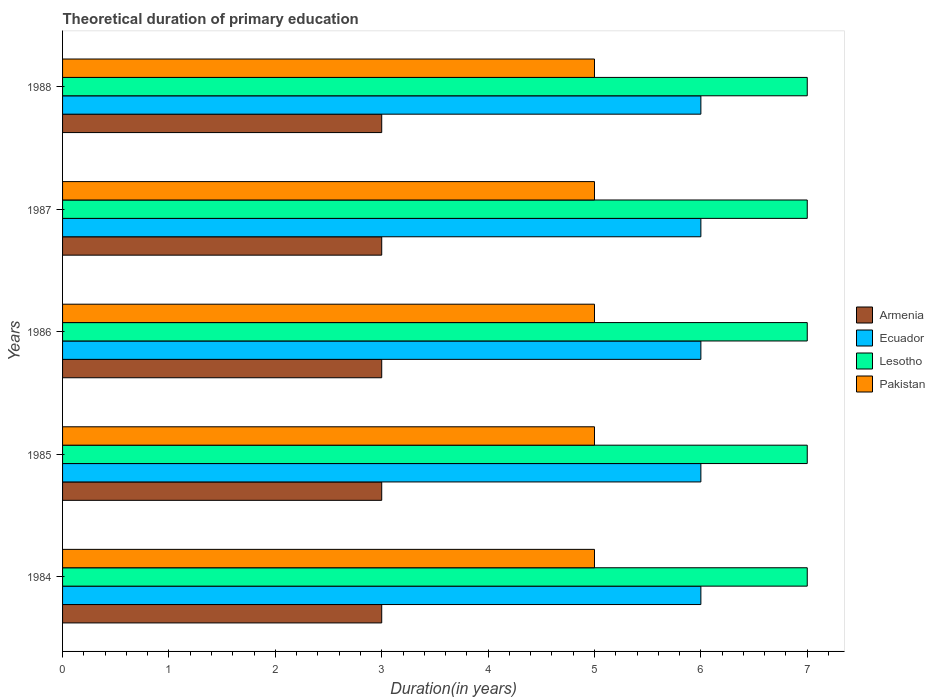How many different coloured bars are there?
Offer a very short reply. 4. How many groups of bars are there?
Give a very brief answer. 5. Are the number of bars on each tick of the Y-axis equal?
Provide a short and direct response. Yes. How many bars are there on the 5th tick from the top?
Your response must be concise. 4. What is the label of the 3rd group of bars from the top?
Provide a short and direct response. 1986. In how many cases, is the number of bars for a given year not equal to the number of legend labels?
Give a very brief answer. 0. Across all years, what is the maximum total theoretical duration of primary education in Pakistan?
Your answer should be compact. 5. Across all years, what is the minimum total theoretical duration of primary education in Armenia?
Give a very brief answer. 3. In which year was the total theoretical duration of primary education in Ecuador maximum?
Ensure brevity in your answer.  1984. In which year was the total theoretical duration of primary education in Armenia minimum?
Your answer should be compact. 1984. What is the total total theoretical duration of primary education in Lesotho in the graph?
Your answer should be compact. 35. What is the difference between the total theoretical duration of primary education in Ecuador in 1987 and the total theoretical duration of primary education in Pakistan in 1984?
Your answer should be compact. 1. In the year 1987, what is the difference between the total theoretical duration of primary education in Armenia and total theoretical duration of primary education in Ecuador?
Your answer should be very brief. -3. In how many years, is the total theoretical duration of primary education in Pakistan greater than 4.2 years?
Offer a terse response. 5. Is the difference between the total theoretical duration of primary education in Armenia in 1984 and 1986 greater than the difference between the total theoretical duration of primary education in Ecuador in 1984 and 1986?
Make the answer very short. No. Is it the case that in every year, the sum of the total theoretical duration of primary education in Ecuador and total theoretical duration of primary education in Armenia is greater than the sum of total theoretical duration of primary education in Lesotho and total theoretical duration of primary education in Pakistan?
Provide a short and direct response. No. What does the 1st bar from the top in 1985 represents?
Give a very brief answer. Pakistan. What does the 2nd bar from the bottom in 1986 represents?
Provide a succinct answer. Ecuador. Is it the case that in every year, the sum of the total theoretical duration of primary education in Pakistan and total theoretical duration of primary education in Armenia is greater than the total theoretical duration of primary education in Ecuador?
Your response must be concise. Yes. How many years are there in the graph?
Your response must be concise. 5. What is the difference between two consecutive major ticks on the X-axis?
Keep it short and to the point. 1. Does the graph contain any zero values?
Provide a short and direct response. No. Does the graph contain grids?
Keep it short and to the point. No. How are the legend labels stacked?
Make the answer very short. Vertical. What is the title of the graph?
Your answer should be compact. Theoretical duration of primary education. What is the label or title of the X-axis?
Keep it short and to the point. Duration(in years). What is the label or title of the Y-axis?
Provide a succinct answer. Years. What is the Duration(in years) in Armenia in 1984?
Make the answer very short. 3. What is the Duration(in years) of Pakistan in 1984?
Offer a very short reply. 5. What is the Duration(in years) of Armenia in 1985?
Your answer should be very brief. 3. What is the Duration(in years) in Ecuador in 1985?
Give a very brief answer. 6. What is the Duration(in years) of Lesotho in 1985?
Offer a terse response. 7. What is the Duration(in years) in Armenia in 1986?
Ensure brevity in your answer.  3. What is the Duration(in years) in Ecuador in 1987?
Your answer should be very brief. 6. What is the Duration(in years) in Lesotho in 1987?
Make the answer very short. 7. What is the Duration(in years) of Ecuador in 1988?
Make the answer very short. 6. What is the Duration(in years) in Pakistan in 1988?
Offer a very short reply. 5. Across all years, what is the maximum Duration(in years) of Armenia?
Your answer should be compact. 3. Across all years, what is the maximum Duration(in years) of Lesotho?
Provide a short and direct response. 7. Across all years, what is the maximum Duration(in years) in Pakistan?
Give a very brief answer. 5. Across all years, what is the minimum Duration(in years) in Armenia?
Provide a short and direct response. 3. Across all years, what is the minimum Duration(in years) in Pakistan?
Provide a short and direct response. 5. What is the total Duration(in years) in Armenia in the graph?
Your answer should be very brief. 15. What is the total Duration(in years) of Ecuador in the graph?
Provide a short and direct response. 30. What is the total Duration(in years) of Lesotho in the graph?
Keep it short and to the point. 35. What is the total Duration(in years) of Pakistan in the graph?
Keep it short and to the point. 25. What is the difference between the Duration(in years) in Ecuador in 1984 and that in 1985?
Your response must be concise. 0. What is the difference between the Duration(in years) in Lesotho in 1984 and that in 1985?
Give a very brief answer. 0. What is the difference between the Duration(in years) of Ecuador in 1984 and that in 1986?
Provide a short and direct response. 0. What is the difference between the Duration(in years) in Lesotho in 1984 and that in 1986?
Provide a succinct answer. 0. What is the difference between the Duration(in years) in Pakistan in 1984 and that in 1986?
Make the answer very short. 0. What is the difference between the Duration(in years) in Ecuador in 1984 and that in 1987?
Provide a short and direct response. 0. What is the difference between the Duration(in years) in Lesotho in 1984 and that in 1987?
Offer a very short reply. 0. What is the difference between the Duration(in years) in Lesotho in 1984 and that in 1988?
Provide a short and direct response. 0. What is the difference between the Duration(in years) in Pakistan in 1984 and that in 1988?
Your response must be concise. 0. What is the difference between the Duration(in years) in Ecuador in 1985 and that in 1987?
Provide a short and direct response. 0. What is the difference between the Duration(in years) of Pakistan in 1985 and that in 1987?
Offer a terse response. 0. What is the difference between the Duration(in years) of Armenia in 1985 and that in 1988?
Your response must be concise. 0. What is the difference between the Duration(in years) in Ecuador in 1985 and that in 1988?
Provide a succinct answer. 0. What is the difference between the Duration(in years) of Lesotho in 1985 and that in 1988?
Give a very brief answer. 0. What is the difference between the Duration(in years) in Pakistan in 1985 and that in 1988?
Give a very brief answer. 0. What is the difference between the Duration(in years) of Lesotho in 1987 and that in 1988?
Provide a short and direct response. 0. What is the difference between the Duration(in years) of Armenia in 1984 and the Duration(in years) of Ecuador in 1985?
Your response must be concise. -3. What is the difference between the Duration(in years) of Ecuador in 1984 and the Duration(in years) of Pakistan in 1985?
Offer a terse response. 1. What is the difference between the Duration(in years) in Armenia in 1984 and the Duration(in years) in Pakistan in 1986?
Ensure brevity in your answer.  -2. What is the difference between the Duration(in years) of Ecuador in 1984 and the Duration(in years) of Lesotho in 1986?
Your answer should be compact. -1. What is the difference between the Duration(in years) in Lesotho in 1984 and the Duration(in years) in Pakistan in 1986?
Provide a short and direct response. 2. What is the difference between the Duration(in years) of Armenia in 1984 and the Duration(in years) of Ecuador in 1987?
Keep it short and to the point. -3. What is the difference between the Duration(in years) of Armenia in 1984 and the Duration(in years) of Lesotho in 1987?
Give a very brief answer. -4. What is the difference between the Duration(in years) of Armenia in 1984 and the Duration(in years) of Pakistan in 1987?
Offer a very short reply. -2. What is the difference between the Duration(in years) of Ecuador in 1984 and the Duration(in years) of Lesotho in 1987?
Provide a short and direct response. -1. What is the difference between the Duration(in years) in Ecuador in 1984 and the Duration(in years) in Pakistan in 1987?
Provide a succinct answer. 1. What is the difference between the Duration(in years) of Lesotho in 1984 and the Duration(in years) of Pakistan in 1987?
Provide a succinct answer. 2. What is the difference between the Duration(in years) of Armenia in 1984 and the Duration(in years) of Ecuador in 1988?
Make the answer very short. -3. What is the difference between the Duration(in years) in Armenia in 1984 and the Duration(in years) in Lesotho in 1988?
Provide a short and direct response. -4. What is the difference between the Duration(in years) of Armenia in 1984 and the Duration(in years) of Pakistan in 1988?
Give a very brief answer. -2. What is the difference between the Duration(in years) of Ecuador in 1984 and the Duration(in years) of Lesotho in 1988?
Offer a very short reply. -1. What is the difference between the Duration(in years) of Ecuador in 1984 and the Duration(in years) of Pakistan in 1988?
Provide a short and direct response. 1. What is the difference between the Duration(in years) in Armenia in 1985 and the Duration(in years) in Ecuador in 1986?
Make the answer very short. -3. What is the difference between the Duration(in years) of Armenia in 1985 and the Duration(in years) of Lesotho in 1986?
Your answer should be compact. -4. What is the difference between the Duration(in years) in Armenia in 1985 and the Duration(in years) in Pakistan in 1986?
Keep it short and to the point. -2. What is the difference between the Duration(in years) of Armenia in 1985 and the Duration(in years) of Lesotho in 1987?
Your answer should be very brief. -4. What is the difference between the Duration(in years) of Armenia in 1985 and the Duration(in years) of Pakistan in 1987?
Provide a succinct answer. -2. What is the difference between the Duration(in years) in Armenia in 1985 and the Duration(in years) in Ecuador in 1988?
Your answer should be compact. -3. What is the difference between the Duration(in years) of Armenia in 1985 and the Duration(in years) of Pakistan in 1988?
Provide a succinct answer. -2. What is the difference between the Duration(in years) of Armenia in 1986 and the Duration(in years) of Ecuador in 1987?
Make the answer very short. -3. What is the difference between the Duration(in years) in Ecuador in 1986 and the Duration(in years) in Lesotho in 1987?
Offer a terse response. -1. What is the difference between the Duration(in years) in Armenia in 1986 and the Duration(in years) in Ecuador in 1988?
Provide a succinct answer. -3. What is the difference between the Duration(in years) in Lesotho in 1986 and the Duration(in years) in Pakistan in 1988?
Provide a succinct answer. 2. What is the difference between the Duration(in years) of Armenia in 1987 and the Duration(in years) of Ecuador in 1988?
Offer a terse response. -3. What is the difference between the Duration(in years) of Armenia in 1987 and the Duration(in years) of Lesotho in 1988?
Make the answer very short. -4. What is the difference between the Duration(in years) of Lesotho in 1987 and the Duration(in years) of Pakistan in 1988?
Your answer should be compact. 2. What is the average Duration(in years) of Lesotho per year?
Your response must be concise. 7. In the year 1984, what is the difference between the Duration(in years) in Armenia and Duration(in years) in Lesotho?
Your answer should be very brief. -4. In the year 1984, what is the difference between the Duration(in years) of Armenia and Duration(in years) of Pakistan?
Your answer should be compact. -2. In the year 1985, what is the difference between the Duration(in years) in Armenia and Duration(in years) in Ecuador?
Provide a short and direct response. -3. In the year 1985, what is the difference between the Duration(in years) of Armenia and Duration(in years) of Lesotho?
Provide a succinct answer. -4. In the year 1985, what is the difference between the Duration(in years) in Ecuador and Duration(in years) in Lesotho?
Keep it short and to the point. -1. In the year 1985, what is the difference between the Duration(in years) of Ecuador and Duration(in years) of Pakistan?
Your answer should be compact. 1. In the year 1985, what is the difference between the Duration(in years) of Lesotho and Duration(in years) of Pakistan?
Your answer should be very brief. 2. In the year 1986, what is the difference between the Duration(in years) of Armenia and Duration(in years) of Ecuador?
Your response must be concise. -3. In the year 1986, what is the difference between the Duration(in years) of Armenia and Duration(in years) of Pakistan?
Ensure brevity in your answer.  -2. In the year 1986, what is the difference between the Duration(in years) in Ecuador and Duration(in years) in Pakistan?
Provide a short and direct response. 1. In the year 1987, what is the difference between the Duration(in years) of Armenia and Duration(in years) of Ecuador?
Provide a short and direct response. -3. In the year 1987, what is the difference between the Duration(in years) of Armenia and Duration(in years) of Lesotho?
Offer a terse response. -4. In the year 1987, what is the difference between the Duration(in years) of Armenia and Duration(in years) of Pakistan?
Your answer should be compact. -2. In the year 1987, what is the difference between the Duration(in years) in Ecuador and Duration(in years) in Lesotho?
Ensure brevity in your answer.  -1. In the year 1987, what is the difference between the Duration(in years) of Lesotho and Duration(in years) of Pakistan?
Ensure brevity in your answer.  2. In the year 1988, what is the difference between the Duration(in years) of Armenia and Duration(in years) of Lesotho?
Make the answer very short. -4. In the year 1988, what is the difference between the Duration(in years) in Armenia and Duration(in years) in Pakistan?
Offer a terse response. -2. In the year 1988, what is the difference between the Duration(in years) in Ecuador and Duration(in years) in Lesotho?
Keep it short and to the point. -1. In the year 1988, what is the difference between the Duration(in years) in Lesotho and Duration(in years) in Pakistan?
Provide a short and direct response. 2. What is the ratio of the Duration(in years) of Pakistan in 1984 to that in 1985?
Your answer should be compact. 1. What is the ratio of the Duration(in years) in Armenia in 1984 to that in 1986?
Make the answer very short. 1. What is the ratio of the Duration(in years) in Ecuador in 1984 to that in 1986?
Your answer should be very brief. 1. What is the ratio of the Duration(in years) of Pakistan in 1984 to that in 1986?
Provide a short and direct response. 1. What is the ratio of the Duration(in years) in Armenia in 1984 to that in 1987?
Provide a succinct answer. 1. What is the ratio of the Duration(in years) of Pakistan in 1984 to that in 1987?
Provide a succinct answer. 1. What is the ratio of the Duration(in years) of Ecuador in 1984 to that in 1988?
Offer a very short reply. 1. What is the ratio of the Duration(in years) in Pakistan in 1984 to that in 1988?
Make the answer very short. 1. What is the ratio of the Duration(in years) of Armenia in 1985 to that in 1986?
Make the answer very short. 1. What is the ratio of the Duration(in years) in Lesotho in 1985 to that in 1986?
Your answer should be compact. 1. What is the ratio of the Duration(in years) in Pakistan in 1985 to that in 1987?
Ensure brevity in your answer.  1. What is the ratio of the Duration(in years) of Armenia in 1985 to that in 1988?
Provide a succinct answer. 1. What is the ratio of the Duration(in years) of Ecuador in 1985 to that in 1988?
Make the answer very short. 1. What is the ratio of the Duration(in years) of Lesotho in 1985 to that in 1988?
Give a very brief answer. 1. What is the ratio of the Duration(in years) of Pakistan in 1985 to that in 1988?
Give a very brief answer. 1. What is the ratio of the Duration(in years) in Armenia in 1986 to that in 1987?
Keep it short and to the point. 1. What is the ratio of the Duration(in years) of Lesotho in 1986 to that in 1987?
Provide a short and direct response. 1. What is the ratio of the Duration(in years) in Pakistan in 1986 to that in 1987?
Make the answer very short. 1. What is the ratio of the Duration(in years) in Ecuador in 1986 to that in 1988?
Give a very brief answer. 1. What is the ratio of the Duration(in years) in Lesotho in 1986 to that in 1988?
Offer a terse response. 1. What is the ratio of the Duration(in years) in Armenia in 1987 to that in 1988?
Offer a very short reply. 1. What is the ratio of the Duration(in years) in Ecuador in 1987 to that in 1988?
Give a very brief answer. 1. What is the ratio of the Duration(in years) of Lesotho in 1987 to that in 1988?
Your answer should be very brief. 1. What is the difference between the highest and the second highest Duration(in years) of Ecuador?
Provide a short and direct response. 0. What is the difference between the highest and the second highest Duration(in years) of Pakistan?
Ensure brevity in your answer.  0. What is the difference between the highest and the lowest Duration(in years) of Armenia?
Provide a succinct answer. 0. What is the difference between the highest and the lowest Duration(in years) in Lesotho?
Your response must be concise. 0. 